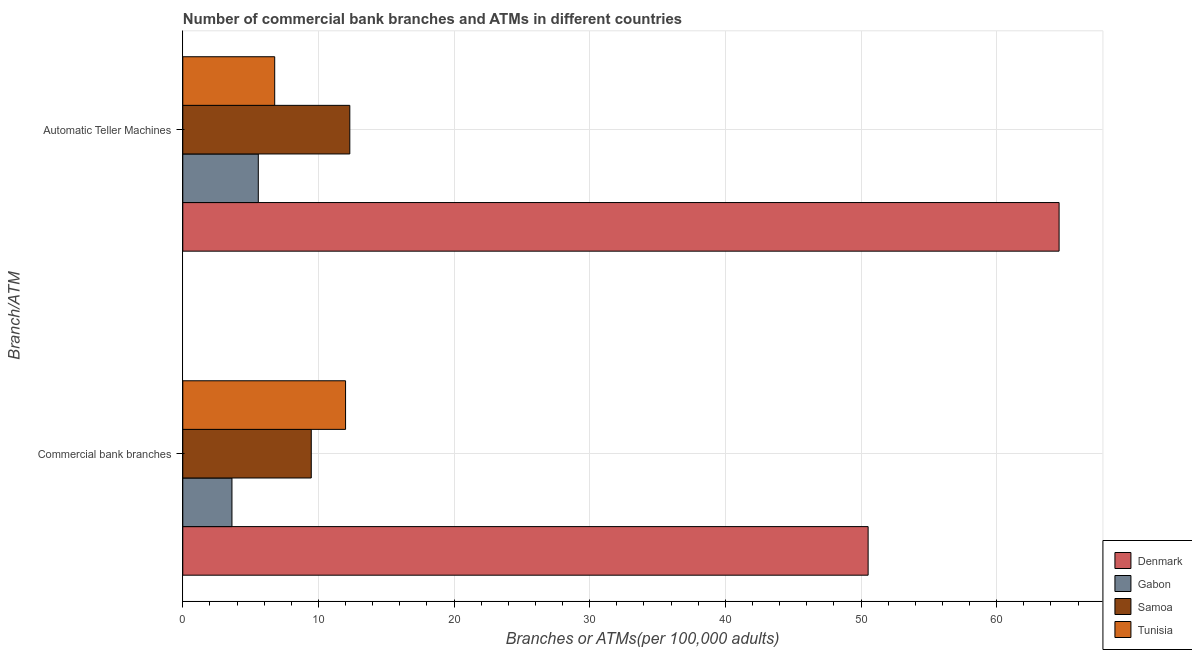How many different coloured bars are there?
Make the answer very short. 4. What is the label of the 1st group of bars from the top?
Ensure brevity in your answer.  Automatic Teller Machines. What is the number of commercal bank branches in Tunisia?
Provide a short and direct response. 12. Across all countries, what is the maximum number of atms?
Provide a succinct answer. 64.61. Across all countries, what is the minimum number of atms?
Offer a terse response. 5.57. In which country was the number of commercal bank branches minimum?
Give a very brief answer. Gabon. What is the total number of commercal bank branches in the graph?
Keep it short and to the point. 75.62. What is the difference between the number of atms in Samoa and that in Gabon?
Offer a very short reply. 6.75. What is the difference between the number of atms in Tunisia and the number of commercal bank branches in Denmark?
Provide a short and direct response. -43.75. What is the average number of atms per country?
Your response must be concise. 22.32. What is the difference between the number of commercal bank branches and number of atms in Denmark?
Ensure brevity in your answer.  -14.08. What is the ratio of the number of commercal bank branches in Denmark to that in Samoa?
Your answer should be compact. 5.33. In how many countries, is the number of atms greater than the average number of atms taken over all countries?
Your answer should be very brief. 1. What does the 2nd bar from the top in Commercial bank branches represents?
Make the answer very short. Samoa. What does the 1st bar from the bottom in Commercial bank branches represents?
Offer a very short reply. Denmark. How many bars are there?
Ensure brevity in your answer.  8. Are the values on the major ticks of X-axis written in scientific E-notation?
Keep it short and to the point. No. Does the graph contain grids?
Your response must be concise. Yes. How many legend labels are there?
Offer a terse response. 4. How are the legend labels stacked?
Provide a succinct answer. Vertical. What is the title of the graph?
Provide a short and direct response. Number of commercial bank branches and ATMs in different countries. Does "Liechtenstein" appear as one of the legend labels in the graph?
Make the answer very short. No. What is the label or title of the X-axis?
Offer a very short reply. Branches or ATMs(per 100,0 adults). What is the label or title of the Y-axis?
Your answer should be very brief. Branch/ATM. What is the Branches or ATMs(per 100,000 adults) of Denmark in Commercial bank branches?
Offer a terse response. 50.53. What is the Branches or ATMs(per 100,000 adults) of Gabon in Commercial bank branches?
Offer a terse response. 3.62. What is the Branches or ATMs(per 100,000 adults) of Samoa in Commercial bank branches?
Provide a short and direct response. 9.47. What is the Branches or ATMs(per 100,000 adults) in Tunisia in Commercial bank branches?
Offer a terse response. 12. What is the Branches or ATMs(per 100,000 adults) of Denmark in Automatic Teller Machines?
Make the answer very short. 64.61. What is the Branches or ATMs(per 100,000 adults) in Gabon in Automatic Teller Machines?
Provide a short and direct response. 5.57. What is the Branches or ATMs(per 100,000 adults) of Samoa in Automatic Teller Machines?
Offer a very short reply. 12.31. What is the Branches or ATMs(per 100,000 adults) of Tunisia in Automatic Teller Machines?
Your answer should be compact. 6.78. Across all Branch/ATM, what is the maximum Branches or ATMs(per 100,000 adults) of Denmark?
Your answer should be compact. 64.61. Across all Branch/ATM, what is the maximum Branches or ATMs(per 100,000 adults) in Gabon?
Keep it short and to the point. 5.57. Across all Branch/ATM, what is the maximum Branches or ATMs(per 100,000 adults) in Samoa?
Your answer should be compact. 12.31. Across all Branch/ATM, what is the maximum Branches or ATMs(per 100,000 adults) in Tunisia?
Provide a short and direct response. 12. Across all Branch/ATM, what is the minimum Branches or ATMs(per 100,000 adults) in Denmark?
Your answer should be compact. 50.53. Across all Branch/ATM, what is the minimum Branches or ATMs(per 100,000 adults) in Gabon?
Keep it short and to the point. 3.62. Across all Branch/ATM, what is the minimum Branches or ATMs(per 100,000 adults) of Samoa?
Your answer should be compact. 9.47. Across all Branch/ATM, what is the minimum Branches or ATMs(per 100,000 adults) in Tunisia?
Offer a very short reply. 6.78. What is the total Branches or ATMs(per 100,000 adults) of Denmark in the graph?
Your answer should be compact. 115.13. What is the total Branches or ATMs(per 100,000 adults) in Gabon in the graph?
Your answer should be compact. 9.19. What is the total Branches or ATMs(per 100,000 adults) in Samoa in the graph?
Give a very brief answer. 21.79. What is the total Branches or ATMs(per 100,000 adults) of Tunisia in the graph?
Provide a short and direct response. 18.78. What is the difference between the Branches or ATMs(per 100,000 adults) of Denmark in Commercial bank branches and that in Automatic Teller Machines?
Ensure brevity in your answer.  -14.08. What is the difference between the Branches or ATMs(per 100,000 adults) in Gabon in Commercial bank branches and that in Automatic Teller Machines?
Your answer should be very brief. -1.94. What is the difference between the Branches or ATMs(per 100,000 adults) of Samoa in Commercial bank branches and that in Automatic Teller Machines?
Offer a terse response. -2.84. What is the difference between the Branches or ATMs(per 100,000 adults) in Tunisia in Commercial bank branches and that in Automatic Teller Machines?
Offer a terse response. 5.22. What is the difference between the Branches or ATMs(per 100,000 adults) of Denmark in Commercial bank branches and the Branches or ATMs(per 100,000 adults) of Gabon in Automatic Teller Machines?
Your answer should be compact. 44.96. What is the difference between the Branches or ATMs(per 100,000 adults) of Denmark in Commercial bank branches and the Branches or ATMs(per 100,000 adults) of Samoa in Automatic Teller Machines?
Provide a succinct answer. 38.21. What is the difference between the Branches or ATMs(per 100,000 adults) in Denmark in Commercial bank branches and the Branches or ATMs(per 100,000 adults) in Tunisia in Automatic Teller Machines?
Give a very brief answer. 43.75. What is the difference between the Branches or ATMs(per 100,000 adults) in Gabon in Commercial bank branches and the Branches or ATMs(per 100,000 adults) in Samoa in Automatic Teller Machines?
Your response must be concise. -8.69. What is the difference between the Branches or ATMs(per 100,000 adults) in Gabon in Commercial bank branches and the Branches or ATMs(per 100,000 adults) in Tunisia in Automatic Teller Machines?
Your answer should be compact. -3.15. What is the difference between the Branches or ATMs(per 100,000 adults) of Samoa in Commercial bank branches and the Branches or ATMs(per 100,000 adults) of Tunisia in Automatic Teller Machines?
Your answer should be compact. 2.7. What is the average Branches or ATMs(per 100,000 adults) of Denmark per Branch/ATM?
Provide a short and direct response. 57.57. What is the average Branches or ATMs(per 100,000 adults) of Gabon per Branch/ATM?
Your answer should be compact. 4.6. What is the average Branches or ATMs(per 100,000 adults) in Samoa per Branch/ATM?
Your answer should be compact. 10.89. What is the average Branches or ATMs(per 100,000 adults) in Tunisia per Branch/ATM?
Give a very brief answer. 9.39. What is the difference between the Branches or ATMs(per 100,000 adults) of Denmark and Branches or ATMs(per 100,000 adults) of Gabon in Commercial bank branches?
Your answer should be compact. 46.9. What is the difference between the Branches or ATMs(per 100,000 adults) in Denmark and Branches or ATMs(per 100,000 adults) in Samoa in Commercial bank branches?
Ensure brevity in your answer.  41.05. What is the difference between the Branches or ATMs(per 100,000 adults) of Denmark and Branches or ATMs(per 100,000 adults) of Tunisia in Commercial bank branches?
Give a very brief answer. 38.53. What is the difference between the Branches or ATMs(per 100,000 adults) in Gabon and Branches or ATMs(per 100,000 adults) in Samoa in Commercial bank branches?
Keep it short and to the point. -5.85. What is the difference between the Branches or ATMs(per 100,000 adults) in Gabon and Branches or ATMs(per 100,000 adults) in Tunisia in Commercial bank branches?
Ensure brevity in your answer.  -8.38. What is the difference between the Branches or ATMs(per 100,000 adults) of Samoa and Branches or ATMs(per 100,000 adults) of Tunisia in Commercial bank branches?
Provide a short and direct response. -2.53. What is the difference between the Branches or ATMs(per 100,000 adults) in Denmark and Branches or ATMs(per 100,000 adults) in Gabon in Automatic Teller Machines?
Give a very brief answer. 59.04. What is the difference between the Branches or ATMs(per 100,000 adults) in Denmark and Branches or ATMs(per 100,000 adults) in Samoa in Automatic Teller Machines?
Offer a very short reply. 52.29. What is the difference between the Branches or ATMs(per 100,000 adults) in Denmark and Branches or ATMs(per 100,000 adults) in Tunisia in Automatic Teller Machines?
Make the answer very short. 57.83. What is the difference between the Branches or ATMs(per 100,000 adults) in Gabon and Branches or ATMs(per 100,000 adults) in Samoa in Automatic Teller Machines?
Provide a short and direct response. -6.75. What is the difference between the Branches or ATMs(per 100,000 adults) of Gabon and Branches or ATMs(per 100,000 adults) of Tunisia in Automatic Teller Machines?
Offer a terse response. -1.21. What is the difference between the Branches or ATMs(per 100,000 adults) of Samoa and Branches or ATMs(per 100,000 adults) of Tunisia in Automatic Teller Machines?
Give a very brief answer. 5.54. What is the ratio of the Branches or ATMs(per 100,000 adults) of Denmark in Commercial bank branches to that in Automatic Teller Machines?
Offer a very short reply. 0.78. What is the ratio of the Branches or ATMs(per 100,000 adults) in Gabon in Commercial bank branches to that in Automatic Teller Machines?
Your answer should be compact. 0.65. What is the ratio of the Branches or ATMs(per 100,000 adults) in Samoa in Commercial bank branches to that in Automatic Teller Machines?
Your answer should be compact. 0.77. What is the ratio of the Branches or ATMs(per 100,000 adults) of Tunisia in Commercial bank branches to that in Automatic Teller Machines?
Your answer should be compact. 1.77. What is the difference between the highest and the second highest Branches or ATMs(per 100,000 adults) in Denmark?
Offer a terse response. 14.08. What is the difference between the highest and the second highest Branches or ATMs(per 100,000 adults) of Gabon?
Your answer should be compact. 1.94. What is the difference between the highest and the second highest Branches or ATMs(per 100,000 adults) of Samoa?
Your answer should be very brief. 2.84. What is the difference between the highest and the second highest Branches or ATMs(per 100,000 adults) of Tunisia?
Provide a short and direct response. 5.22. What is the difference between the highest and the lowest Branches or ATMs(per 100,000 adults) in Denmark?
Give a very brief answer. 14.08. What is the difference between the highest and the lowest Branches or ATMs(per 100,000 adults) of Gabon?
Give a very brief answer. 1.94. What is the difference between the highest and the lowest Branches or ATMs(per 100,000 adults) of Samoa?
Your answer should be compact. 2.84. What is the difference between the highest and the lowest Branches or ATMs(per 100,000 adults) in Tunisia?
Ensure brevity in your answer.  5.22. 